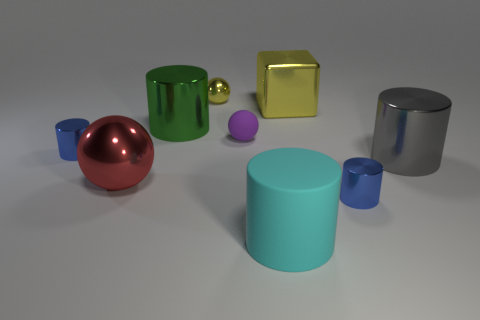Are there the same number of large yellow blocks that are behind the tiny yellow object and big cyan cubes?
Your answer should be compact. Yes. What is the size of the metal ball behind the big yellow thing?
Ensure brevity in your answer.  Small. What number of small things are either gray rubber things or yellow metal balls?
Your answer should be very brief. 1. There is a small shiny thing that is the same shape as the small rubber object; what is its color?
Keep it short and to the point. Yellow. Is the block the same size as the green cylinder?
Make the answer very short. Yes. How many things are either tiny shiny balls or small blue cylinders that are left of the green metal object?
Provide a succinct answer. 2. What is the color of the rubber object behind the small shiny cylinder in front of the large gray shiny thing?
Keep it short and to the point. Purple. There is a big metal cylinder left of the tiny purple thing; is it the same color as the big rubber object?
Make the answer very short. No. What is the blue cylinder to the left of the big cyan cylinder made of?
Your response must be concise. Metal. What is the size of the purple sphere?
Your answer should be compact. Small. 